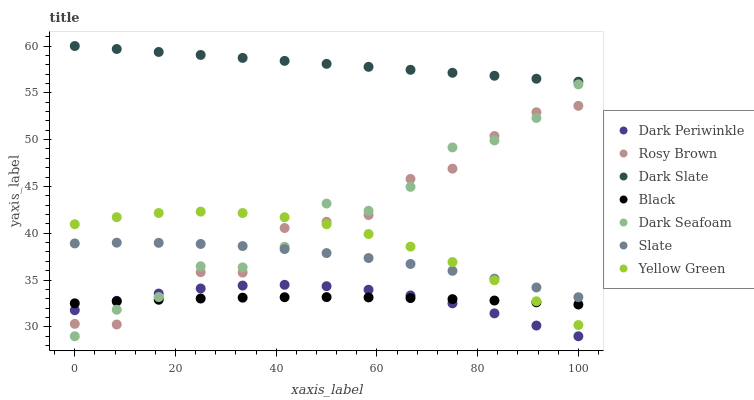Does Black have the minimum area under the curve?
Answer yes or no. Yes. Does Dark Slate have the maximum area under the curve?
Answer yes or no. Yes. Does Slate have the minimum area under the curve?
Answer yes or no. No. Does Slate have the maximum area under the curve?
Answer yes or no. No. Is Dark Slate the smoothest?
Answer yes or no. Yes. Is Dark Seafoam the roughest?
Answer yes or no. Yes. Is Slate the smoothest?
Answer yes or no. No. Is Slate the roughest?
Answer yes or no. No. Does Dark Seafoam have the lowest value?
Answer yes or no. Yes. Does Slate have the lowest value?
Answer yes or no. No. Does Dark Slate have the highest value?
Answer yes or no. Yes. Does Slate have the highest value?
Answer yes or no. No. Is Yellow Green less than Dark Slate?
Answer yes or no. Yes. Is Dark Slate greater than Black?
Answer yes or no. Yes. Does Rosy Brown intersect Dark Seafoam?
Answer yes or no. Yes. Is Rosy Brown less than Dark Seafoam?
Answer yes or no. No. Is Rosy Brown greater than Dark Seafoam?
Answer yes or no. No. Does Yellow Green intersect Dark Slate?
Answer yes or no. No. 